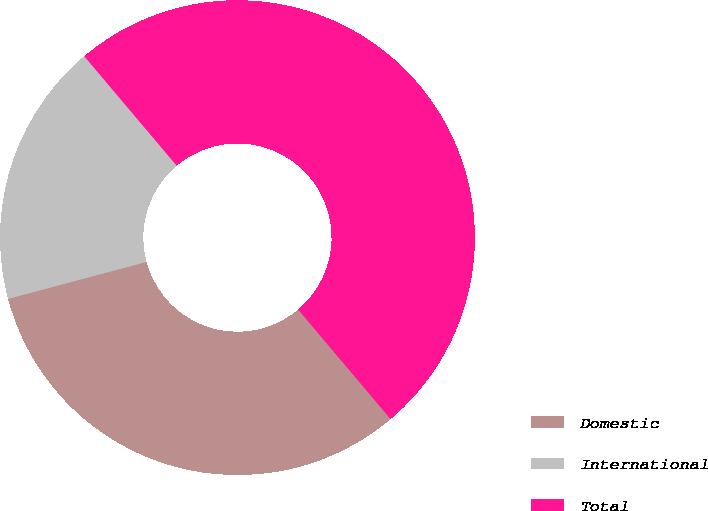<chart> <loc_0><loc_0><loc_500><loc_500><pie_chart><fcel>Domestic<fcel>International<fcel>Total<nl><fcel>32.01%<fcel>17.99%<fcel>50.0%<nl></chart> 